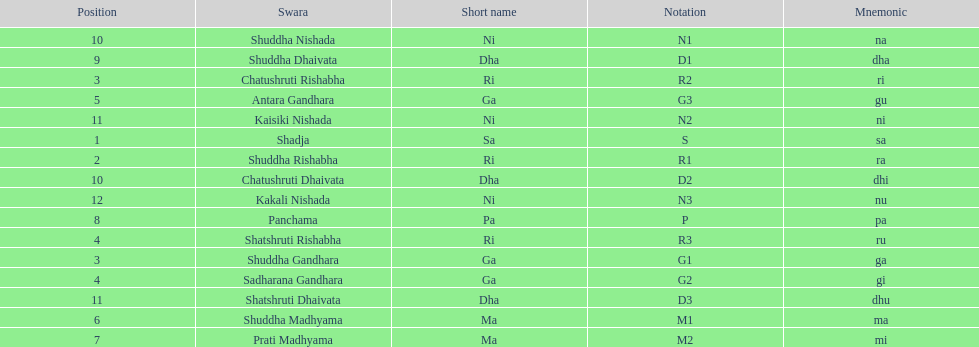Which swara holds the last position? Kakali Nishada. 